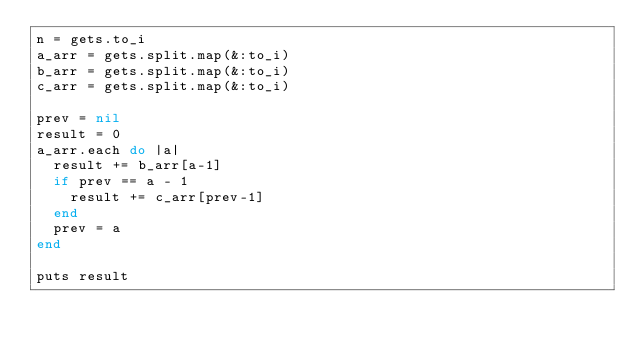Convert code to text. <code><loc_0><loc_0><loc_500><loc_500><_Ruby_>n = gets.to_i
a_arr = gets.split.map(&:to_i)
b_arr = gets.split.map(&:to_i)
c_arr = gets.split.map(&:to_i)

prev = nil
result = 0
a_arr.each do |a|
  result += b_arr[a-1]
  if prev == a - 1
    result += c_arr[prev-1]
  end
  prev = a
end

puts result
</code> 